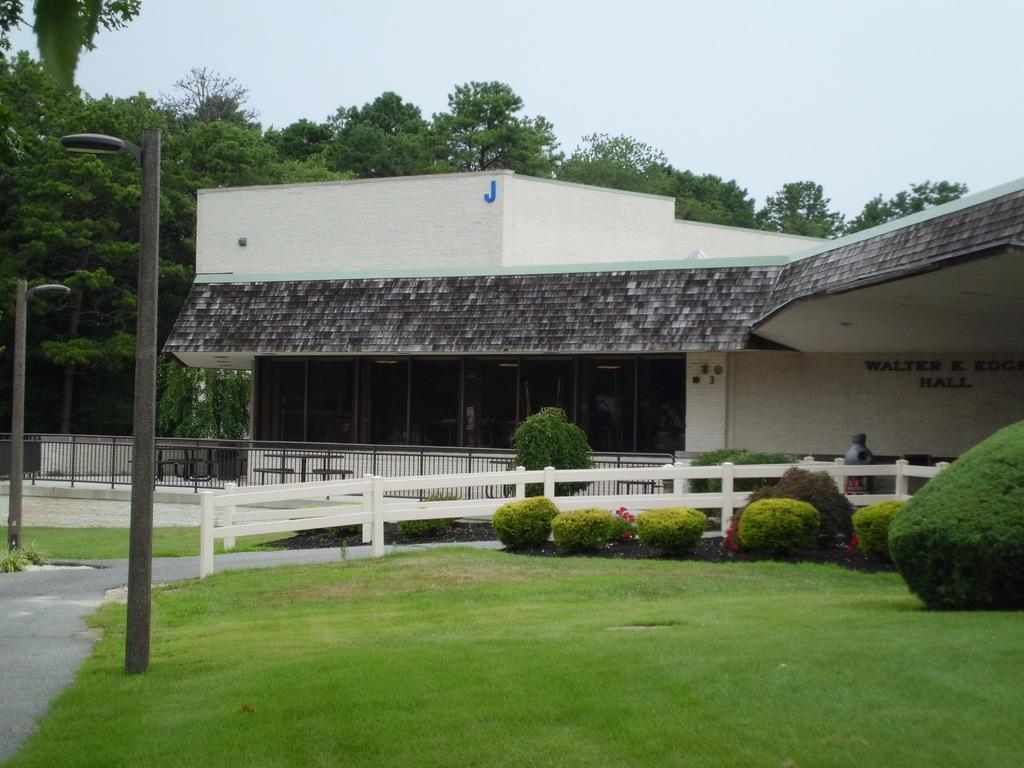What can be seen in the foreground of the image? In the foreground of the image, there are poles, plants, grass, and a railing. What is visible in the background of the image? In the background of the image, there is a building, trees, and the sky. What type of vegetation is present in the foreground of the image? Plants and grass are present in the foreground of the image. Can you describe the railing in the foreground of the image? The railing in the foreground of the image is a barrier or boundary. What type of cherries are being served for dinner in the image? There is no mention of cherries or dinner in the image; it features poles, plants, grass, a railing, a building, trees, and the sky. 